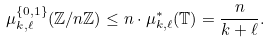<formula> <loc_0><loc_0><loc_500><loc_500>\mu _ { k , \ell } ^ { \{ 0 , 1 \} } ( \mathbb { Z } / n \mathbb { Z } ) \leq n \cdot \mu ^ { * } _ { k , \ell } ( \mathbb { T } ) = \frac { n } { k + \ell } .</formula> 